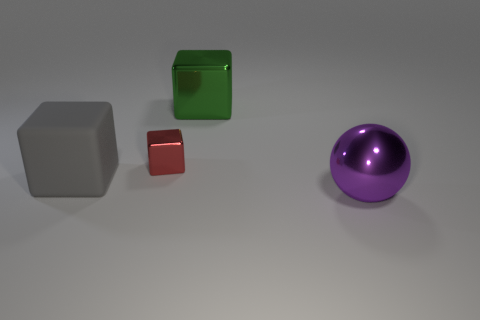Is there a gray block that is on the left side of the metal object that is right of the large metallic thing behind the purple metallic sphere?
Give a very brief answer. Yes. There is a purple thing that is the same size as the green metallic cube; what shape is it?
Offer a terse response. Sphere. There is a purple object in front of the gray rubber thing; is it the same size as the block on the left side of the red metallic object?
Your answer should be very brief. Yes. How many green shiny blocks are there?
Your response must be concise. 1. What is the size of the thing in front of the gray object in front of the large block that is on the right side of the matte block?
Give a very brief answer. Large. Is the color of the rubber thing the same as the sphere?
Provide a short and direct response. No. Is there anything else that has the same size as the purple thing?
Provide a short and direct response. Yes. What number of gray rubber objects are in front of the sphere?
Your response must be concise. 0. Are there the same number of large rubber blocks that are to the right of the large green block and large gray metal things?
Offer a terse response. Yes. How many objects are big purple metal spheres or red metallic cubes?
Ensure brevity in your answer.  2. 